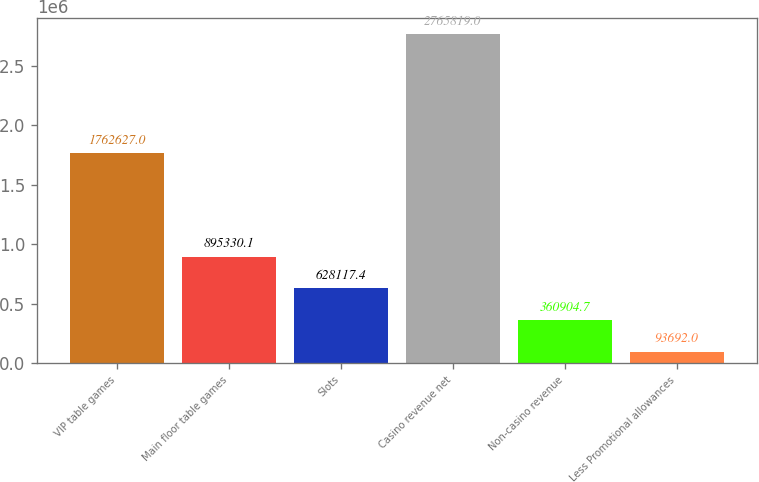Convert chart to OTSL. <chart><loc_0><loc_0><loc_500><loc_500><bar_chart><fcel>VIP table games<fcel>Main floor table games<fcel>Slots<fcel>Casino revenue net<fcel>Non-casino revenue<fcel>Less Promotional allowances<nl><fcel>1.76263e+06<fcel>895330<fcel>628117<fcel>2.76582e+06<fcel>360905<fcel>93692<nl></chart> 